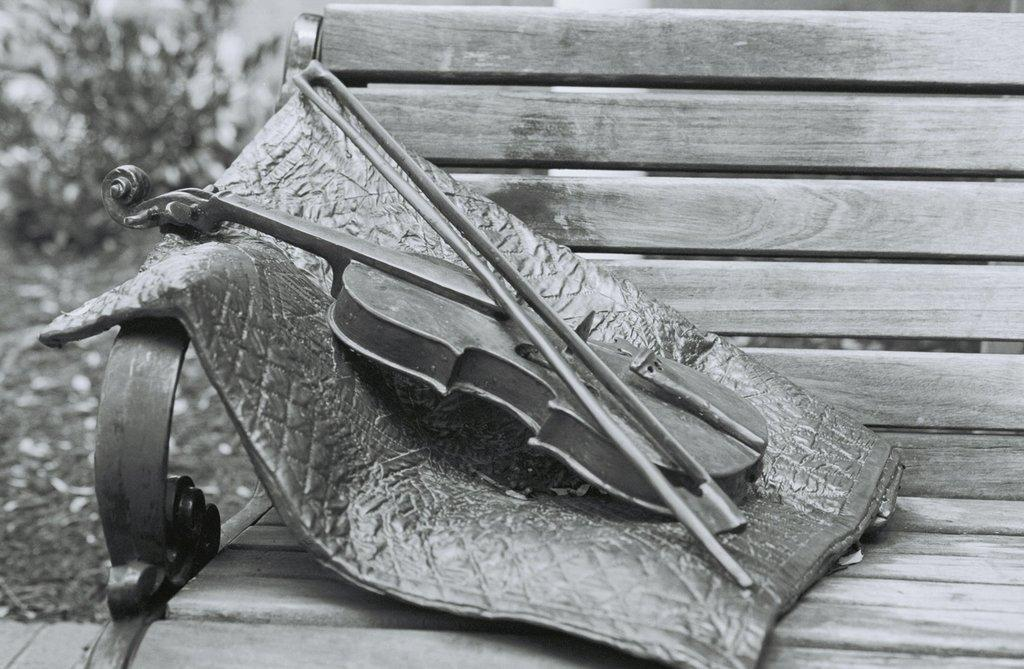What is the color scheme of the image? The image is black and white. What musical instrument can be seen in the image? There is a violin with a bow in the image. What is located on the bench in the image? There is an object on the bench. What type of vegetation is visible behind the bench? There are trees behind the bench. How does the violin fall off the bench in the image? The violin does not fall off the bench in the image; it is resting on the bench with the bow. Can you see any signs of the violin burning in the image? There are no signs of the violin burning in the image; it appears to be in good condition. 